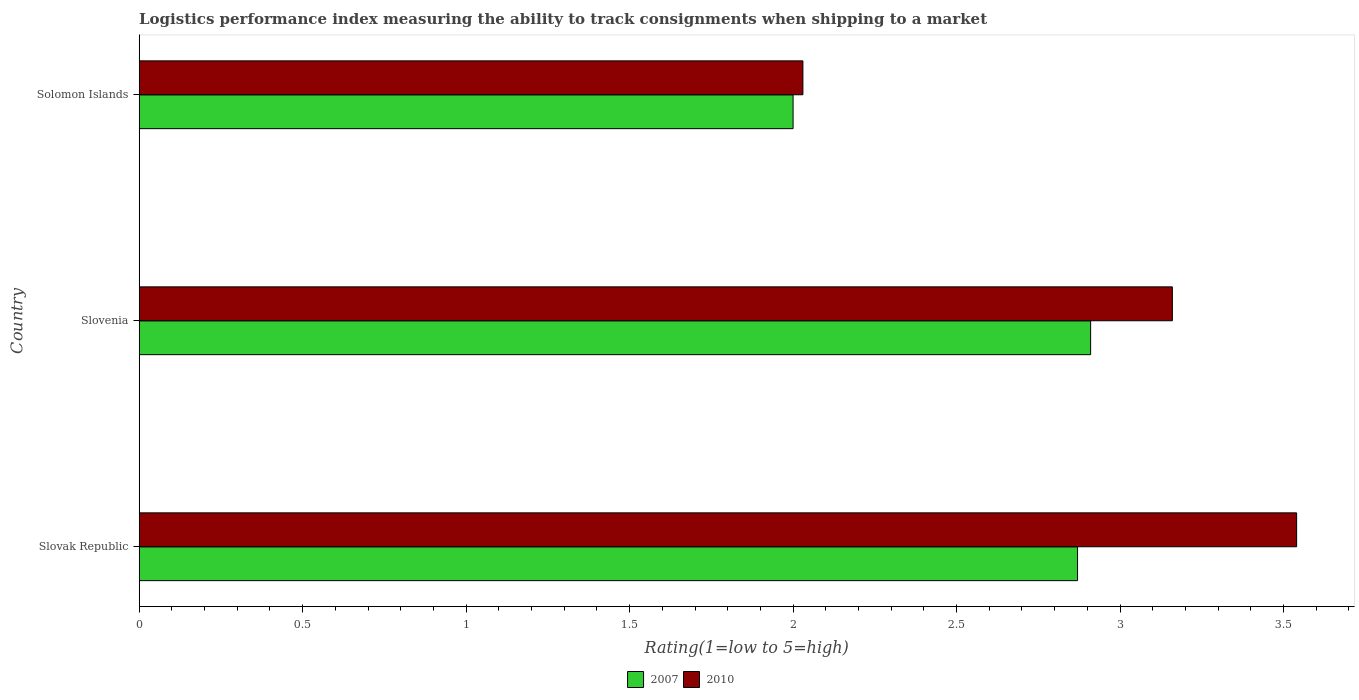How many different coloured bars are there?
Keep it short and to the point. 2. How many groups of bars are there?
Offer a terse response. 3. How many bars are there on the 3rd tick from the bottom?
Give a very brief answer. 2. What is the label of the 3rd group of bars from the top?
Offer a terse response. Slovak Republic. What is the Logistic performance index in 2010 in Slovak Republic?
Your response must be concise. 3.54. Across all countries, what is the maximum Logistic performance index in 2007?
Offer a very short reply. 2.91. Across all countries, what is the minimum Logistic performance index in 2010?
Provide a short and direct response. 2.03. In which country was the Logistic performance index in 2010 maximum?
Ensure brevity in your answer.  Slovak Republic. In which country was the Logistic performance index in 2010 minimum?
Provide a short and direct response. Solomon Islands. What is the total Logistic performance index in 2007 in the graph?
Keep it short and to the point. 7.78. What is the difference between the Logistic performance index in 2010 in Slovenia and that in Solomon Islands?
Keep it short and to the point. 1.13. What is the difference between the Logistic performance index in 2010 in Slovenia and the Logistic performance index in 2007 in Solomon Islands?
Your answer should be very brief. 1.16. What is the average Logistic performance index in 2007 per country?
Keep it short and to the point. 2.59. In how many countries, is the Logistic performance index in 2007 greater than 2.9 ?
Keep it short and to the point. 1. What is the ratio of the Logistic performance index in 2010 in Slovenia to that in Solomon Islands?
Your answer should be very brief. 1.56. Is the Logistic performance index in 2007 in Slovak Republic less than that in Solomon Islands?
Your answer should be very brief. No. Is the difference between the Logistic performance index in 2010 in Slovak Republic and Slovenia greater than the difference between the Logistic performance index in 2007 in Slovak Republic and Slovenia?
Ensure brevity in your answer.  Yes. What is the difference between the highest and the second highest Logistic performance index in 2010?
Make the answer very short. 0.38. What is the difference between the highest and the lowest Logistic performance index in 2007?
Give a very brief answer. 0.91. How many bars are there?
Keep it short and to the point. 6. Are all the bars in the graph horizontal?
Give a very brief answer. Yes. How many countries are there in the graph?
Your answer should be compact. 3. Are the values on the major ticks of X-axis written in scientific E-notation?
Keep it short and to the point. No. How are the legend labels stacked?
Your response must be concise. Horizontal. What is the title of the graph?
Your response must be concise. Logistics performance index measuring the ability to track consignments when shipping to a market. What is the label or title of the X-axis?
Ensure brevity in your answer.  Rating(1=low to 5=high). What is the Rating(1=low to 5=high) of 2007 in Slovak Republic?
Make the answer very short. 2.87. What is the Rating(1=low to 5=high) of 2010 in Slovak Republic?
Offer a very short reply. 3.54. What is the Rating(1=low to 5=high) of 2007 in Slovenia?
Offer a terse response. 2.91. What is the Rating(1=low to 5=high) of 2010 in Slovenia?
Provide a short and direct response. 3.16. What is the Rating(1=low to 5=high) of 2007 in Solomon Islands?
Give a very brief answer. 2. What is the Rating(1=low to 5=high) of 2010 in Solomon Islands?
Provide a short and direct response. 2.03. Across all countries, what is the maximum Rating(1=low to 5=high) of 2007?
Offer a very short reply. 2.91. Across all countries, what is the maximum Rating(1=low to 5=high) in 2010?
Give a very brief answer. 3.54. Across all countries, what is the minimum Rating(1=low to 5=high) of 2007?
Keep it short and to the point. 2. Across all countries, what is the minimum Rating(1=low to 5=high) of 2010?
Your response must be concise. 2.03. What is the total Rating(1=low to 5=high) of 2007 in the graph?
Provide a succinct answer. 7.78. What is the total Rating(1=low to 5=high) in 2010 in the graph?
Provide a succinct answer. 8.73. What is the difference between the Rating(1=low to 5=high) of 2007 in Slovak Republic and that in Slovenia?
Keep it short and to the point. -0.04. What is the difference between the Rating(1=low to 5=high) of 2010 in Slovak Republic and that in Slovenia?
Offer a terse response. 0.38. What is the difference between the Rating(1=low to 5=high) of 2007 in Slovak Republic and that in Solomon Islands?
Make the answer very short. 0.87. What is the difference between the Rating(1=low to 5=high) in 2010 in Slovak Republic and that in Solomon Islands?
Ensure brevity in your answer.  1.51. What is the difference between the Rating(1=low to 5=high) in 2007 in Slovenia and that in Solomon Islands?
Keep it short and to the point. 0.91. What is the difference between the Rating(1=low to 5=high) of 2010 in Slovenia and that in Solomon Islands?
Give a very brief answer. 1.13. What is the difference between the Rating(1=low to 5=high) in 2007 in Slovak Republic and the Rating(1=low to 5=high) in 2010 in Slovenia?
Keep it short and to the point. -0.29. What is the difference between the Rating(1=low to 5=high) in 2007 in Slovak Republic and the Rating(1=low to 5=high) in 2010 in Solomon Islands?
Your response must be concise. 0.84. What is the average Rating(1=low to 5=high) of 2007 per country?
Provide a short and direct response. 2.59. What is the average Rating(1=low to 5=high) of 2010 per country?
Provide a succinct answer. 2.91. What is the difference between the Rating(1=low to 5=high) of 2007 and Rating(1=low to 5=high) of 2010 in Slovak Republic?
Offer a very short reply. -0.67. What is the difference between the Rating(1=low to 5=high) of 2007 and Rating(1=low to 5=high) of 2010 in Slovenia?
Offer a very short reply. -0.25. What is the difference between the Rating(1=low to 5=high) of 2007 and Rating(1=low to 5=high) of 2010 in Solomon Islands?
Ensure brevity in your answer.  -0.03. What is the ratio of the Rating(1=low to 5=high) in 2007 in Slovak Republic to that in Slovenia?
Ensure brevity in your answer.  0.99. What is the ratio of the Rating(1=low to 5=high) in 2010 in Slovak Republic to that in Slovenia?
Your answer should be compact. 1.12. What is the ratio of the Rating(1=low to 5=high) of 2007 in Slovak Republic to that in Solomon Islands?
Provide a succinct answer. 1.44. What is the ratio of the Rating(1=low to 5=high) of 2010 in Slovak Republic to that in Solomon Islands?
Provide a short and direct response. 1.74. What is the ratio of the Rating(1=low to 5=high) in 2007 in Slovenia to that in Solomon Islands?
Provide a short and direct response. 1.46. What is the ratio of the Rating(1=low to 5=high) of 2010 in Slovenia to that in Solomon Islands?
Offer a very short reply. 1.56. What is the difference between the highest and the second highest Rating(1=low to 5=high) of 2010?
Provide a succinct answer. 0.38. What is the difference between the highest and the lowest Rating(1=low to 5=high) of 2007?
Offer a very short reply. 0.91. What is the difference between the highest and the lowest Rating(1=low to 5=high) in 2010?
Give a very brief answer. 1.51. 